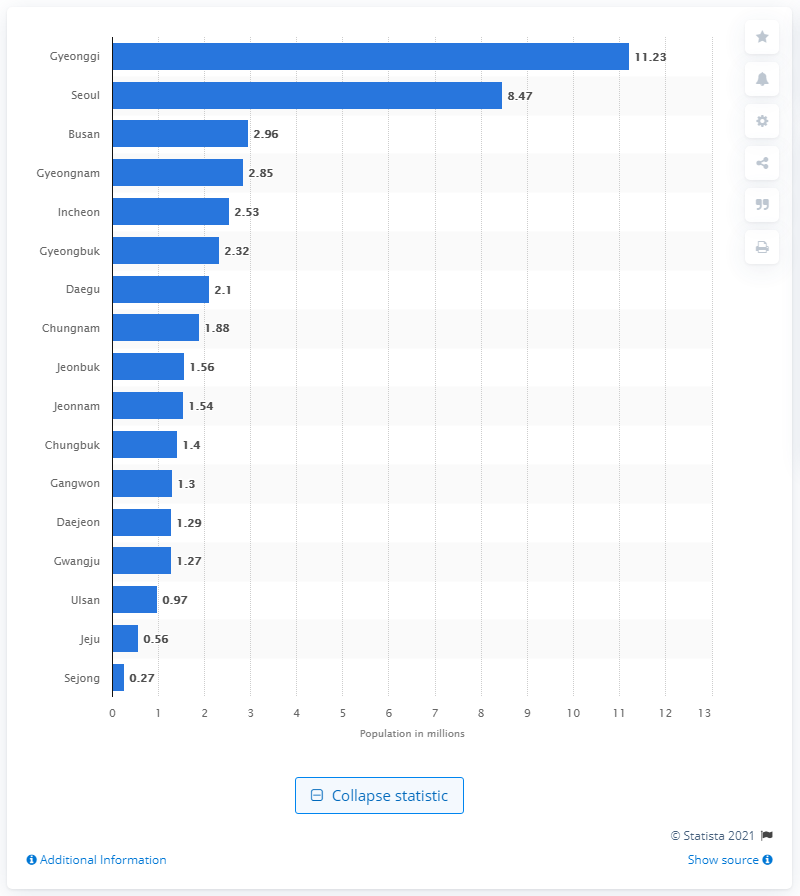Specify some key components in this picture. In 2019, there were approximately 11.23 million people over the age of 15 living in Gyeonggi-do. 